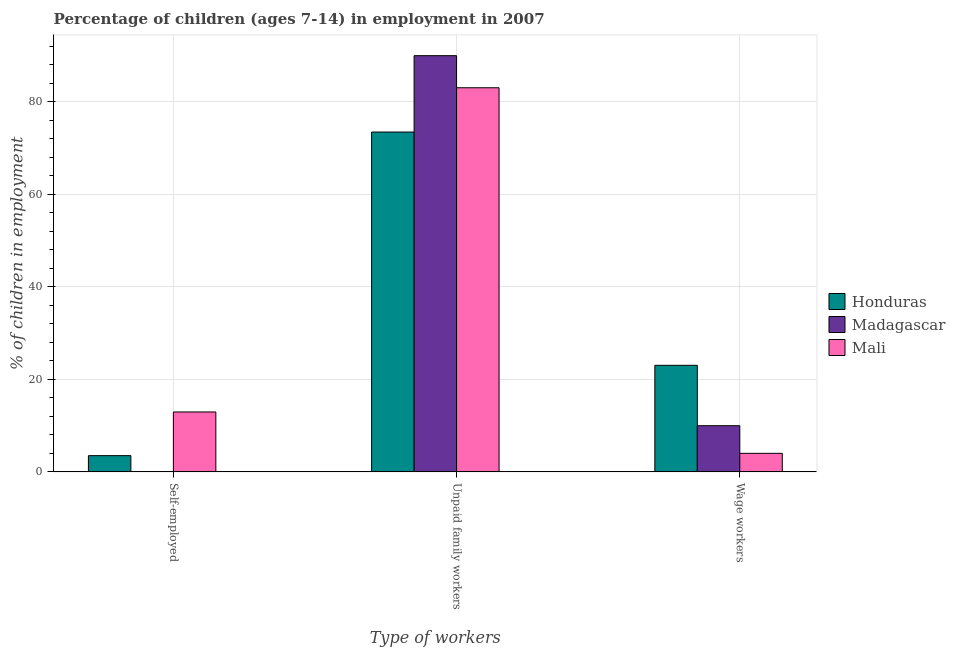How many groups of bars are there?
Provide a short and direct response. 3. How many bars are there on the 2nd tick from the right?
Ensure brevity in your answer.  3. What is the label of the 1st group of bars from the left?
Offer a very short reply. Self-employed. What is the percentage of children employed as wage workers in Honduras?
Your answer should be very brief. 23.04. Across all countries, what is the maximum percentage of self employed children?
Offer a very short reply. 12.96. Across all countries, what is the minimum percentage of self employed children?
Give a very brief answer. 0.05. In which country was the percentage of self employed children maximum?
Your answer should be compact. Mali. In which country was the percentage of children employed as unpaid family workers minimum?
Offer a very short reply. Honduras. What is the total percentage of self employed children in the graph?
Provide a succinct answer. 16.53. What is the difference between the percentage of children employed as wage workers in Honduras and that in Mali?
Your response must be concise. 19.02. What is the difference between the percentage of children employed as unpaid family workers in Madagascar and the percentage of children employed as wage workers in Mali?
Your response must be concise. 85.93. What is the average percentage of children employed as wage workers per country?
Provide a succinct answer. 12.35. What is the difference between the percentage of children employed as wage workers and percentage of children employed as unpaid family workers in Honduras?
Make the answer very short. -50.41. In how many countries, is the percentage of children employed as wage workers greater than 32 %?
Your answer should be compact. 0. What is the ratio of the percentage of children employed as wage workers in Mali to that in Honduras?
Your answer should be compact. 0.17. Is the percentage of children employed as unpaid family workers in Madagascar less than that in Mali?
Your answer should be very brief. No. Is the difference between the percentage of children employed as unpaid family workers in Mali and Madagascar greater than the difference between the percentage of self employed children in Mali and Madagascar?
Your answer should be compact. No. What is the difference between the highest and the second highest percentage of children employed as wage workers?
Offer a terse response. 13.05. What is the difference between the highest and the lowest percentage of children employed as wage workers?
Your answer should be compact. 19.02. In how many countries, is the percentage of children employed as unpaid family workers greater than the average percentage of children employed as unpaid family workers taken over all countries?
Ensure brevity in your answer.  2. What does the 2nd bar from the left in Wage workers represents?
Your response must be concise. Madagascar. What does the 1st bar from the right in Unpaid family workers represents?
Provide a succinct answer. Mali. Are all the bars in the graph horizontal?
Offer a terse response. No. What is the difference between two consecutive major ticks on the Y-axis?
Ensure brevity in your answer.  20. Where does the legend appear in the graph?
Provide a short and direct response. Center right. How many legend labels are there?
Your response must be concise. 3. What is the title of the graph?
Provide a succinct answer. Percentage of children (ages 7-14) in employment in 2007. What is the label or title of the X-axis?
Provide a succinct answer. Type of workers. What is the label or title of the Y-axis?
Ensure brevity in your answer.  % of children in employment. What is the % of children in employment in Honduras in Self-employed?
Your answer should be compact. 3.52. What is the % of children in employment of Madagascar in Self-employed?
Offer a terse response. 0.05. What is the % of children in employment of Mali in Self-employed?
Ensure brevity in your answer.  12.96. What is the % of children in employment of Honduras in Unpaid family workers?
Your response must be concise. 73.45. What is the % of children in employment of Madagascar in Unpaid family workers?
Provide a succinct answer. 89.95. What is the % of children in employment of Mali in Unpaid family workers?
Provide a short and direct response. 83.02. What is the % of children in employment in Honduras in Wage workers?
Provide a succinct answer. 23.04. What is the % of children in employment of Madagascar in Wage workers?
Provide a short and direct response. 9.99. What is the % of children in employment in Mali in Wage workers?
Offer a very short reply. 4.02. Across all Type of workers, what is the maximum % of children in employment in Honduras?
Provide a succinct answer. 73.45. Across all Type of workers, what is the maximum % of children in employment of Madagascar?
Ensure brevity in your answer.  89.95. Across all Type of workers, what is the maximum % of children in employment of Mali?
Provide a succinct answer. 83.02. Across all Type of workers, what is the minimum % of children in employment of Honduras?
Offer a very short reply. 3.52. Across all Type of workers, what is the minimum % of children in employment in Mali?
Your response must be concise. 4.02. What is the total % of children in employment in Honduras in the graph?
Keep it short and to the point. 100.01. What is the total % of children in employment in Madagascar in the graph?
Your answer should be compact. 99.99. What is the difference between the % of children in employment of Honduras in Self-employed and that in Unpaid family workers?
Provide a succinct answer. -69.93. What is the difference between the % of children in employment in Madagascar in Self-employed and that in Unpaid family workers?
Your answer should be compact. -89.9. What is the difference between the % of children in employment in Mali in Self-employed and that in Unpaid family workers?
Offer a very short reply. -70.06. What is the difference between the % of children in employment of Honduras in Self-employed and that in Wage workers?
Your answer should be compact. -19.52. What is the difference between the % of children in employment of Madagascar in Self-employed and that in Wage workers?
Make the answer very short. -9.94. What is the difference between the % of children in employment of Mali in Self-employed and that in Wage workers?
Give a very brief answer. 8.94. What is the difference between the % of children in employment in Honduras in Unpaid family workers and that in Wage workers?
Your response must be concise. 50.41. What is the difference between the % of children in employment in Madagascar in Unpaid family workers and that in Wage workers?
Offer a very short reply. 79.96. What is the difference between the % of children in employment of Mali in Unpaid family workers and that in Wage workers?
Provide a succinct answer. 79. What is the difference between the % of children in employment in Honduras in Self-employed and the % of children in employment in Madagascar in Unpaid family workers?
Your answer should be compact. -86.43. What is the difference between the % of children in employment in Honduras in Self-employed and the % of children in employment in Mali in Unpaid family workers?
Your response must be concise. -79.5. What is the difference between the % of children in employment in Madagascar in Self-employed and the % of children in employment in Mali in Unpaid family workers?
Provide a succinct answer. -82.97. What is the difference between the % of children in employment in Honduras in Self-employed and the % of children in employment in Madagascar in Wage workers?
Keep it short and to the point. -6.47. What is the difference between the % of children in employment of Honduras in Self-employed and the % of children in employment of Mali in Wage workers?
Ensure brevity in your answer.  -0.5. What is the difference between the % of children in employment of Madagascar in Self-employed and the % of children in employment of Mali in Wage workers?
Ensure brevity in your answer.  -3.97. What is the difference between the % of children in employment of Honduras in Unpaid family workers and the % of children in employment of Madagascar in Wage workers?
Provide a succinct answer. 63.46. What is the difference between the % of children in employment in Honduras in Unpaid family workers and the % of children in employment in Mali in Wage workers?
Give a very brief answer. 69.43. What is the difference between the % of children in employment in Madagascar in Unpaid family workers and the % of children in employment in Mali in Wage workers?
Your answer should be compact. 85.93. What is the average % of children in employment of Honduras per Type of workers?
Make the answer very short. 33.34. What is the average % of children in employment in Madagascar per Type of workers?
Your answer should be very brief. 33.33. What is the average % of children in employment in Mali per Type of workers?
Give a very brief answer. 33.33. What is the difference between the % of children in employment in Honduras and % of children in employment in Madagascar in Self-employed?
Your answer should be very brief. 3.47. What is the difference between the % of children in employment in Honduras and % of children in employment in Mali in Self-employed?
Your response must be concise. -9.44. What is the difference between the % of children in employment of Madagascar and % of children in employment of Mali in Self-employed?
Give a very brief answer. -12.91. What is the difference between the % of children in employment of Honduras and % of children in employment of Madagascar in Unpaid family workers?
Make the answer very short. -16.5. What is the difference between the % of children in employment in Honduras and % of children in employment in Mali in Unpaid family workers?
Provide a short and direct response. -9.57. What is the difference between the % of children in employment of Madagascar and % of children in employment of Mali in Unpaid family workers?
Keep it short and to the point. 6.93. What is the difference between the % of children in employment in Honduras and % of children in employment in Madagascar in Wage workers?
Offer a very short reply. 13.05. What is the difference between the % of children in employment of Honduras and % of children in employment of Mali in Wage workers?
Provide a succinct answer. 19.02. What is the difference between the % of children in employment in Madagascar and % of children in employment in Mali in Wage workers?
Your answer should be very brief. 5.97. What is the ratio of the % of children in employment of Honduras in Self-employed to that in Unpaid family workers?
Your response must be concise. 0.05. What is the ratio of the % of children in employment in Madagascar in Self-employed to that in Unpaid family workers?
Your answer should be compact. 0. What is the ratio of the % of children in employment in Mali in Self-employed to that in Unpaid family workers?
Provide a short and direct response. 0.16. What is the ratio of the % of children in employment in Honduras in Self-employed to that in Wage workers?
Provide a succinct answer. 0.15. What is the ratio of the % of children in employment of Madagascar in Self-employed to that in Wage workers?
Provide a short and direct response. 0.01. What is the ratio of the % of children in employment in Mali in Self-employed to that in Wage workers?
Give a very brief answer. 3.22. What is the ratio of the % of children in employment of Honduras in Unpaid family workers to that in Wage workers?
Provide a succinct answer. 3.19. What is the ratio of the % of children in employment of Madagascar in Unpaid family workers to that in Wage workers?
Offer a very short reply. 9. What is the ratio of the % of children in employment in Mali in Unpaid family workers to that in Wage workers?
Keep it short and to the point. 20.65. What is the difference between the highest and the second highest % of children in employment of Honduras?
Offer a very short reply. 50.41. What is the difference between the highest and the second highest % of children in employment of Madagascar?
Provide a short and direct response. 79.96. What is the difference between the highest and the second highest % of children in employment of Mali?
Offer a terse response. 70.06. What is the difference between the highest and the lowest % of children in employment of Honduras?
Give a very brief answer. 69.93. What is the difference between the highest and the lowest % of children in employment in Madagascar?
Provide a short and direct response. 89.9. What is the difference between the highest and the lowest % of children in employment in Mali?
Provide a short and direct response. 79. 